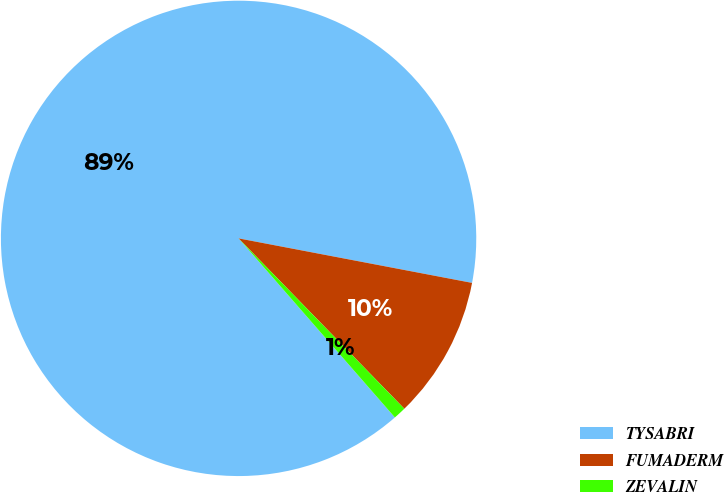Convert chart. <chart><loc_0><loc_0><loc_500><loc_500><pie_chart><fcel>TYSABRI<fcel>FUMADERM<fcel>ZEVALIN<nl><fcel>89.42%<fcel>9.72%<fcel>0.86%<nl></chart> 